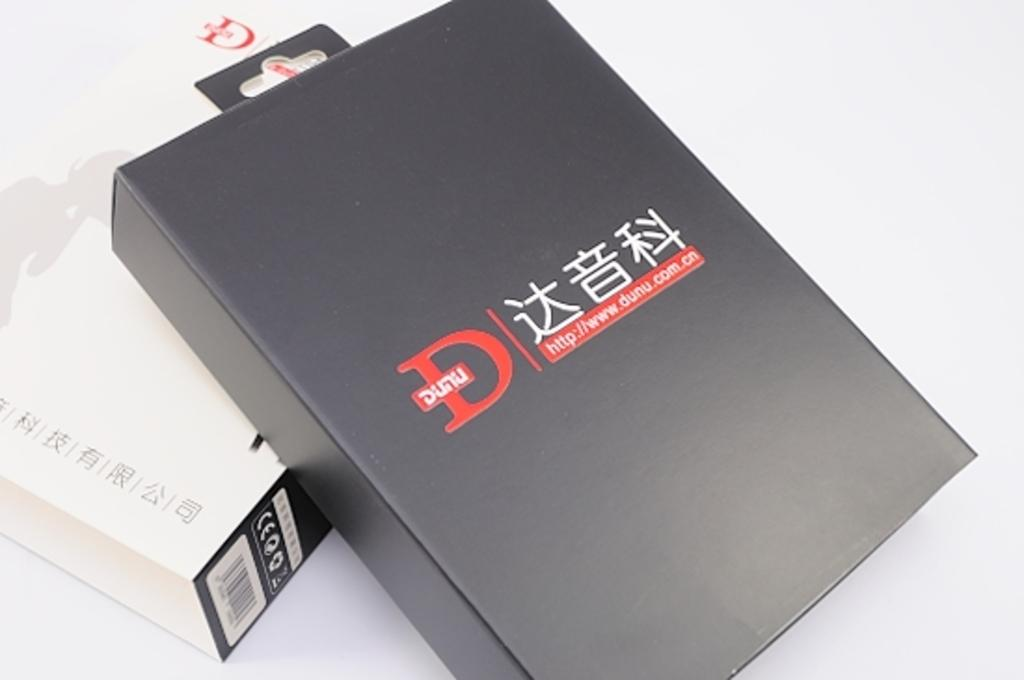<image>
Create a compact narrative representing the image presented. a box with the url adress od http://www.dunu.com 